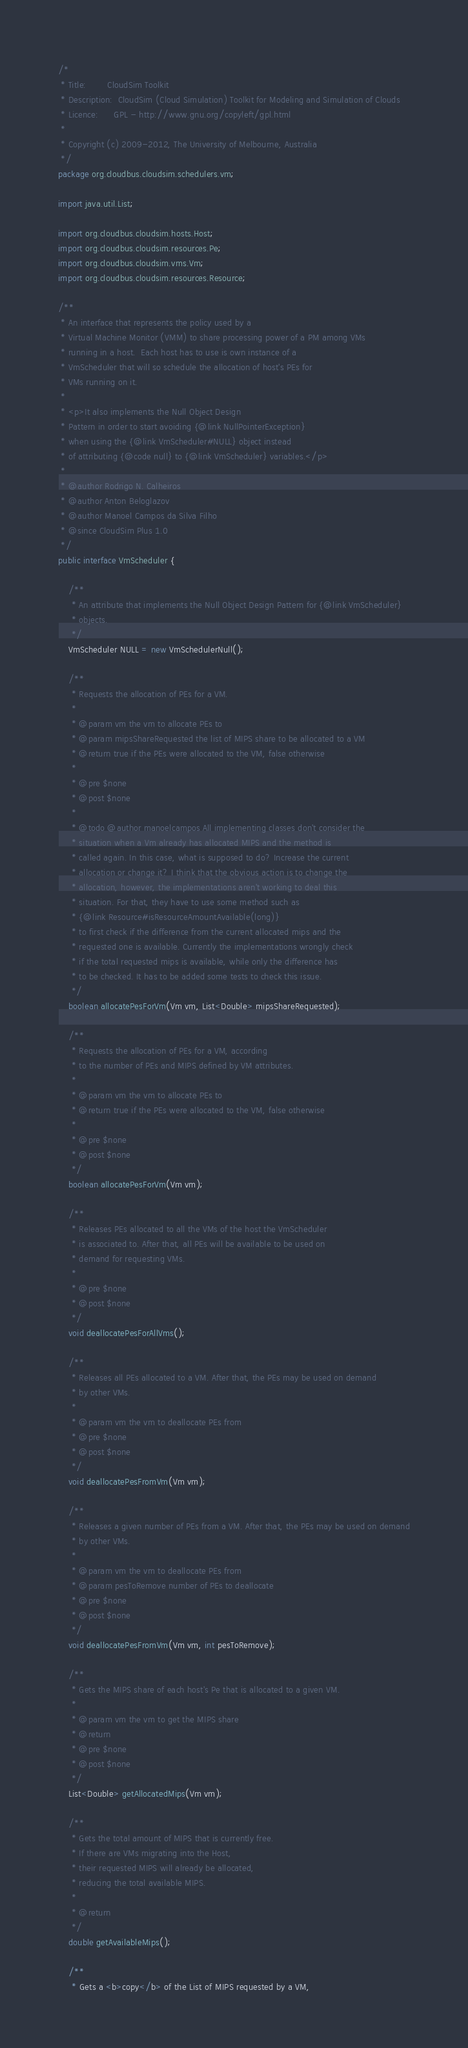<code> <loc_0><loc_0><loc_500><loc_500><_Java_>/*
 * Title:        CloudSim Toolkit
 * Description:  CloudSim (Cloud Simulation) Toolkit for Modeling and Simulation of Clouds
 * Licence:      GPL - http://www.gnu.org/copyleft/gpl.html
 *
 * Copyright (c) 2009-2012, The University of Melbourne, Australia
 */
package org.cloudbus.cloudsim.schedulers.vm;

import java.util.List;

import org.cloudbus.cloudsim.hosts.Host;
import org.cloudbus.cloudsim.resources.Pe;
import org.cloudbus.cloudsim.vms.Vm;
import org.cloudbus.cloudsim.resources.Resource;

/**
 * An interface that represents the policy used by a
 * Virtual Machine Monitor (VMM) to share processing power of a PM among VMs
 * running in a host.  Each host has to use is own instance of a
 * VmScheduler that will so schedule the allocation of host's PEs for
 * VMs running on it.
 *
 * <p>It also implements the Null Object Design
 * Pattern in order to start avoiding {@link NullPointerException}
 * when using the {@link VmScheduler#NULL} object instead
 * of attributing {@code null} to {@link VmScheduler} variables.</p>
 *
 * @author Rodrigo N. Calheiros
 * @author Anton Beloglazov
 * @author Manoel Campos da Silva Filho
 * @since CloudSim Plus 1.0
 */
public interface VmScheduler {

    /**
     * An attribute that implements the Null Object Design Pattern for {@link VmScheduler}
     * objects.
     */
    VmScheduler NULL = new VmSchedulerNull();

    /**
     * Requests the allocation of PEs for a VM.
     *
     * @param vm the vm to allocate PEs to
     * @param mipsShareRequested the list of MIPS share to be allocated to a VM
     * @return true if the PEs were allocated to the VM, false otherwise
     *
     * @pre $none
     * @post $none
     *
     * @todo @author manoelcampos All implementing classes don't consider the
     * situation when a Vm already has allocated MIPS and the method is
     * called again. In this case, what is supposed to do? Increase the current
     * allocation or change it? I think that the obvious action is to change the
     * allocation, however, the implementations aren't working to deal this
     * situation. For that, they have to use some method such as
     * {@link Resource#isResourceAmountAvailable(long)}
     * to first check if the difference from the current allocated mips and the
     * requested one is available. Currently the implementations wrongly check
     * if the total requested mips is available, while only the difference has
     * to be checked. It has to be added some tests to check this issue.
     */
    boolean allocatePesForVm(Vm vm, List<Double> mipsShareRequested);

    /**
     * Requests the allocation of PEs for a VM, according
     * to the number of PEs and MIPS defined by VM attributes.
     *
     * @param vm the vm to allocate PEs to
     * @return true if the PEs were allocated to the VM, false otherwise
     *
     * @pre $none
     * @post $none
     */
    boolean allocatePesForVm(Vm vm);

    /**
     * Releases PEs allocated to all the VMs of the host the VmScheduler
     * is associated to. After that, all PEs will be available to be used on
     * demand for requesting VMs.
     *
     * @pre $none
     * @post $none
     */
    void deallocatePesForAllVms();

    /**
     * Releases all PEs allocated to a VM. After that, the PEs may be used on demand
     * by other VMs.
     *
     * @param vm the vm to deallocate PEs from
     * @pre $none
     * @post $none
     */
    void deallocatePesFromVm(Vm vm);

    /**
     * Releases a given number of PEs from a VM. After that, the PEs may be used on demand
     * by other VMs.
     *
     * @param vm the vm to deallocate PEs from
     * @param pesToRemove number of PEs to deallocate
     * @pre $none
     * @post $none
     */
    void deallocatePesFromVm(Vm vm, int pesToRemove);

    /**
     * Gets the MIPS share of each host's Pe that is allocated to a given VM.
     *
     * @param vm the vm to get the MIPS share
     * @return
     * @pre $none
     * @post $none
     */
    List<Double> getAllocatedMips(Vm vm);

    /**
     * Gets the total amount of MIPS that is currently free.
     * If there are VMs migrating into the Host,
     * their requested MIPS will already be allocated,
     * reducing the total available MIPS.
     *
     * @return
     */
    double getAvailableMips();

    /**
     * Gets a <b>copy</b> of the List of MIPS requested by a VM,</code> 